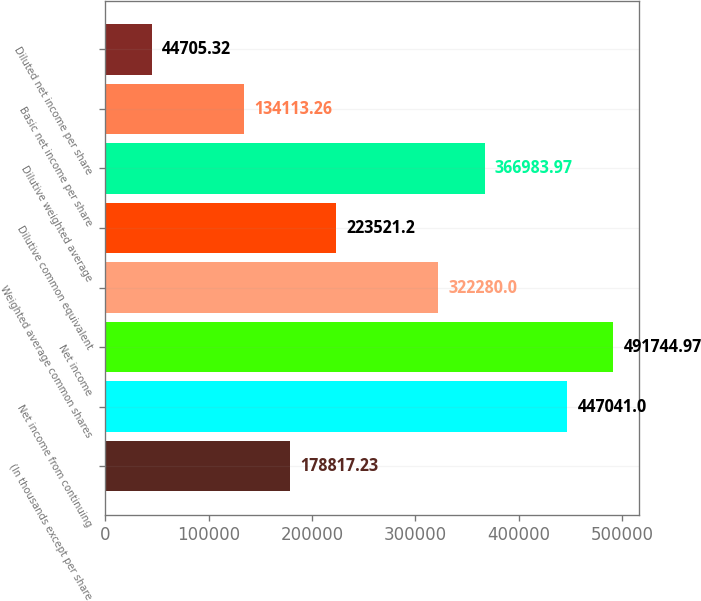Convert chart to OTSL. <chart><loc_0><loc_0><loc_500><loc_500><bar_chart><fcel>(In thousands except per share<fcel>Net income from continuing<fcel>Net income<fcel>Weighted average common shares<fcel>Dilutive common equivalent<fcel>Dilutive weighted average<fcel>Basic net income per share<fcel>Diluted net income per share<nl><fcel>178817<fcel>447041<fcel>491745<fcel>322280<fcel>223521<fcel>366984<fcel>134113<fcel>44705.3<nl></chart> 